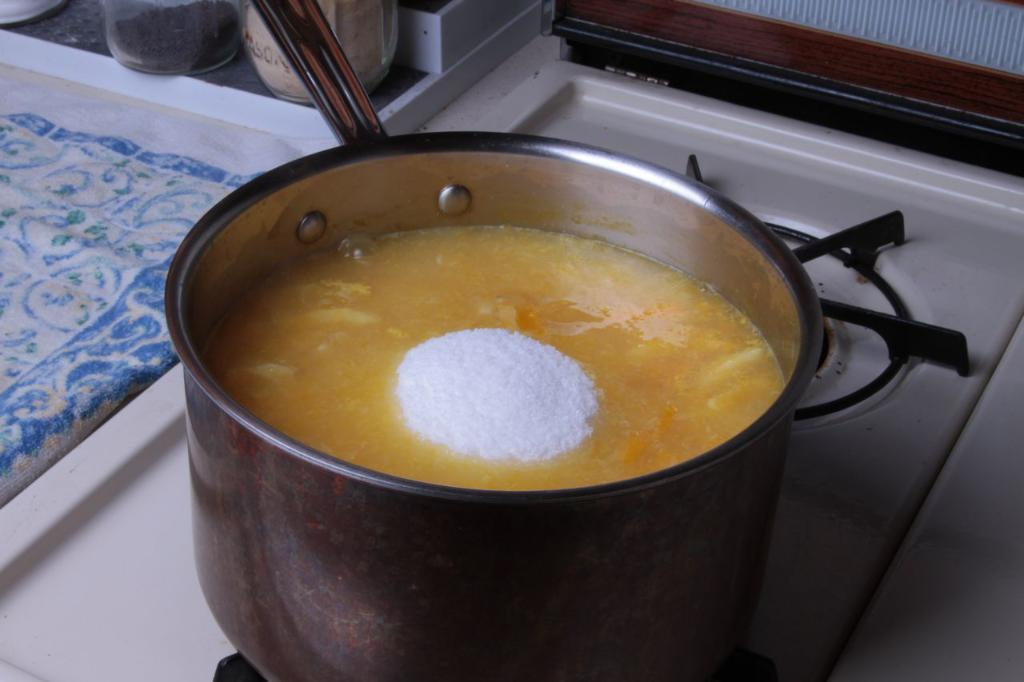What is the main object in the center of the image? There is a stove in the center of the image. What is being cooked on the stove? A vessel containing a food item is on the stove. What can be seen in the background of the image? There are bottles and a cloth in the background, as well as a wall. What type of songs can be heard playing from the frame in the image? There is no frame or music present in the image; it features a stove with a vessel on it and items in the background. 